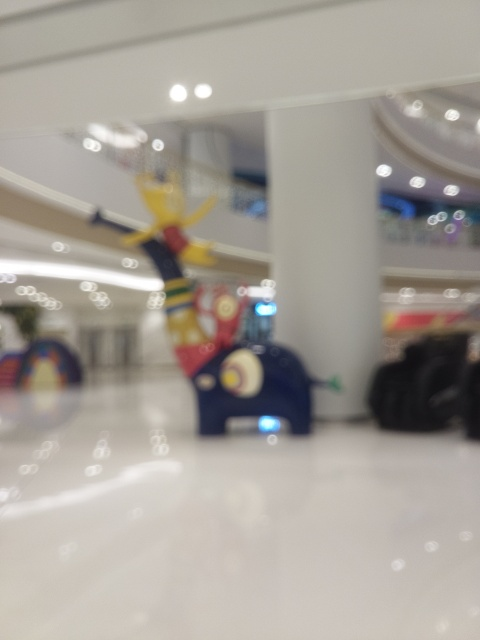What can we infer about the atmosphere or mood in this location based on the image? The warm lighting and the showcase of vibrant colors in the sculpture give the location a welcoming and lively atmosphere. The blur lends a dreamy quality to the scene, hinting at a bustling environment that has been momentarily stilled to focus on the art piece. 